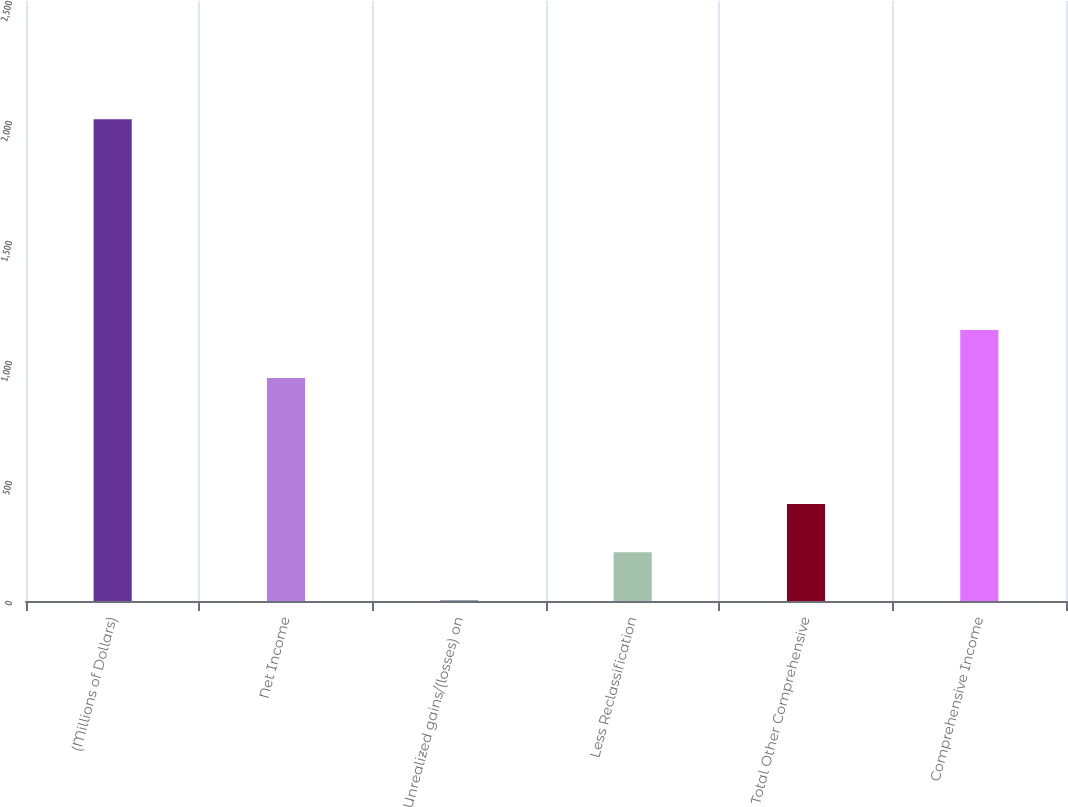Convert chart. <chart><loc_0><loc_0><loc_500><loc_500><bar_chart><fcel>(Millions of Dollars)<fcel>Net Income<fcel>Unrealized gains/(losses) on<fcel>Less Reclassification<fcel>Total Other Comprehensive<fcel>Comprehensive Income<nl><fcel>2007<fcel>929<fcel>3<fcel>203.4<fcel>403.8<fcel>1129.4<nl></chart> 